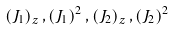<formula> <loc_0><loc_0><loc_500><loc_500>\left ( J _ { 1 } \right ) _ { z } , \left ( J _ { 1 } \right ) ^ { 2 } , \left ( J _ { 2 } \right ) _ { z } , \left ( J _ { 2 } \right ) ^ { 2 }</formula> 